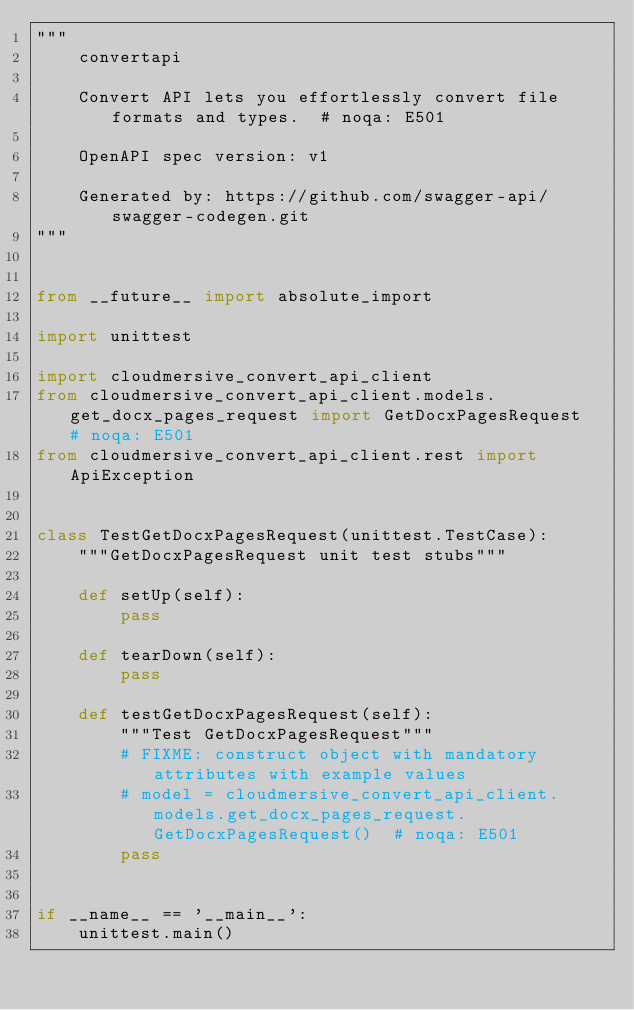<code> <loc_0><loc_0><loc_500><loc_500><_Python_>"""
    convertapi

    Convert API lets you effortlessly convert file formats and types.  # noqa: E501

    OpenAPI spec version: v1
    
    Generated by: https://github.com/swagger-api/swagger-codegen.git
"""


from __future__ import absolute_import

import unittest

import cloudmersive_convert_api_client
from cloudmersive_convert_api_client.models.get_docx_pages_request import GetDocxPagesRequest  # noqa: E501
from cloudmersive_convert_api_client.rest import ApiException


class TestGetDocxPagesRequest(unittest.TestCase):
    """GetDocxPagesRequest unit test stubs"""

    def setUp(self):
        pass

    def tearDown(self):
        pass

    def testGetDocxPagesRequest(self):
        """Test GetDocxPagesRequest"""
        # FIXME: construct object with mandatory attributes with example values
        # model = cloudmersive_convert_api_client.models.get_docx_pages_request.GetDocxPagesRequest()  # noqa: E501
        pass


if __name__ == '__main__':
    unittest.main()
</code> 